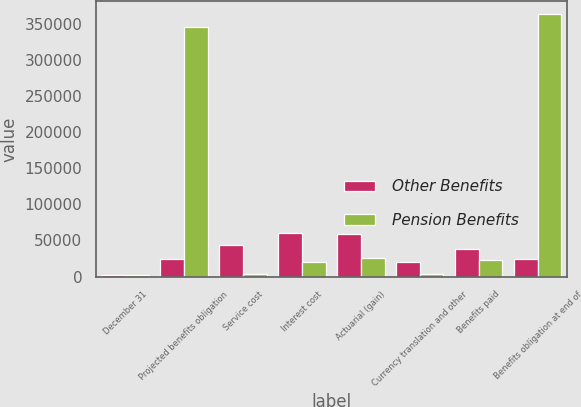Convert chart. <chart><loc_0><loc_0><loc_500><loc_500><stacked_bar_chart><ecel><fcel>December 31<fcel>Projected benefits obligation<fcel>Service cost<fcel>Interest cost<fcel>Actuarial (gain)<fcel>Currency translation and other<fcel>Benefits paid<fcel>Benefits obligation at end of<nl><fcel>Other Benefits<fcel>2007<fcel>24176.5<fcel>43462<fcel>59918<fcel>58905<fcel>20309<fcel>38236<fcel>24176.5<nl><fcel>Pension Benefits<fcel>2007<fcel>345116<fcel>3899<fcel>19762<fcel>25543<fcel>3445<fcel>22810<fcel>362916<nl></chart> 